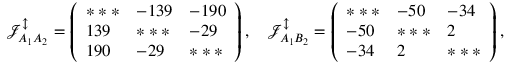Convert formula to latex. <formula><loc_0><loc_0><loc_500><loc_500>\mathcal { J } _ { A _ { 1 } A _ { 2 } } ^ { \updownarrow } = \left ( \begin{array} { l l l } { * * * } & { - 1 3 9 } & { - 1 9 0 } \\ { 1 3 9 } & { * * * } & { - 2 9 } \\ { 1 9 0 } & { - 2 9 } & { * * * } \end{array} \right ) , \quad \mathcal { J } _ { A _ { 1 } B _ { 2 } } ^ { \updownarrow } = \left ( \begin{array} { l l l } { * * * } & { - 5 0 } & { - 3 4 } \\ { - 5 0 } & { * * * } & { 2 } \\ { - 3 4 } & { 2 } & { * * * } \end{array} \right ) ,</formula> 